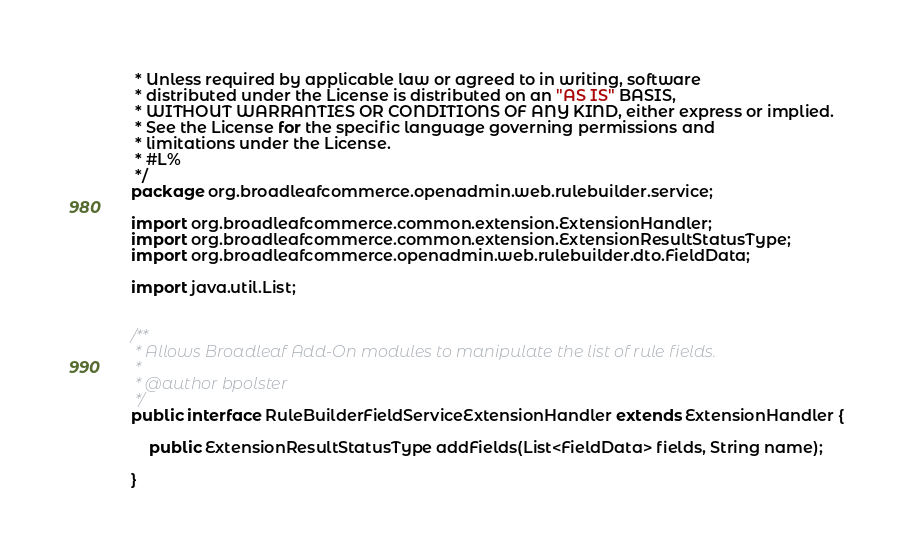<code> <loc_0><loc_0><loc_500><loc_500><_Java_> * Unless required by applicable law or agreed to in writing, software
 * distributed under the License is distributed on an "AS IS" BASIS,
 * WITHOUT WARRANTIES OR CONDITIONS OF ANY KIND, either express or implied.
 * See the License for the specific language governing permissions and
 * limitations under the License.
 * #L%
 */
package org.broadleafcommerce.openadmin.web.rulebuilder.service;

import org.broadleafcommerce.common.extension.ExtensionHandler;
import org.broadleafcommerce.common.extension.ExtensionResultStatusType;
import org.broadleafcommerce.openadmin.web.rulebuilder.dto.FieldData;

import java.util.List;


/**
 * Allows Broadleaf Add-On modules to manipulate the list of rule fields.
 * 
 * @author bpolster
 */
public interface RuleBuilderFieldServiceExtensionHandler extends ExtensionHandler {
    
    public ExtensionResultStatusType addFields(List<FieldData> fields, String name);

}
</code> 